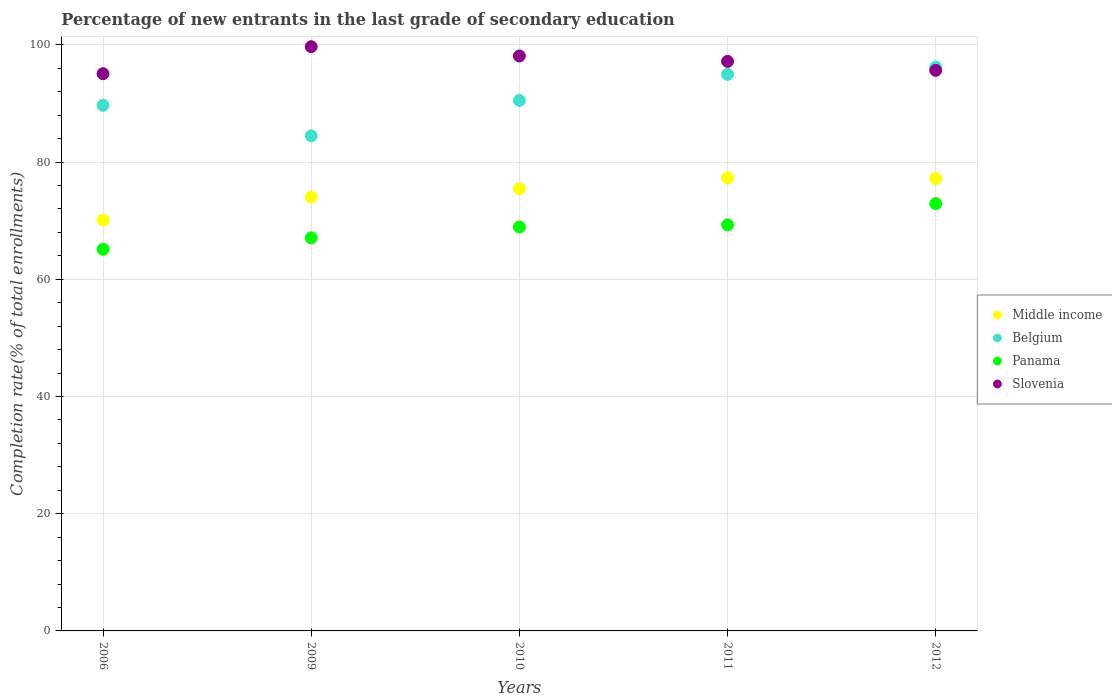What is the percentage of new entrants in Middle income in 2012?
Offer a very short reply. 77.19. Across all years, what is the maximum percentage of new entrants in Middle income?
Ensure brevity in your answer.  77.31. Across all years, what is the minimum percentage of new entrants in Panama?
Give a very brief answer. 65.11. In which year was the percentage of new entrants in Slovenia maximum?
Offer a very short reply. 2009. In which year was the percentage of new entrants in Slovenia minimum?
Your response must be concise. 2006. What is the total percentage of new entrants in Panama in the graph?
Provide a short and direct response. 343.26. What is the difference between the percentage of new entrants in Belgium in 2009 and that in 2010?
Your answer should be very brief. -6.04. What is the difference between the percentage of new entrants in Slovenia in 2006 and the percentage of new entrants in Panama in 2009?
Provide a succinct answer. 28. What is the average percentage of new entrants in Slovenia per year?
Your answer should be compact. 97.13. In the year 2006, what is the difference between the percentage of new entrants in Belgium and percentage of new entrants in Middle income?
Keep it short and to the point. 19.57. In how many years, is the percentage of new entrants in Belgium greater than 80 %?
Provide a short and direct response. 5. What is the ratio of the percentage of new entrants in Panama in 2009 to that in 2010?
Keep it short and to the point. 0.97. What is the difference between the highest and the second highest percentage of new entrants in Panama?
Your response must be concise. 3.62. What is the difference between the highest and the lowest percentage of new entrants in Belgium?
Your answer should be very brief. 11.74. Is it the case that in every year, the sum of the percentage of new entrants in Slovenia and percentage of new entrants in Belgium  is greater than the sum of percentage of new entrants in Middle income and percentage of new entrants in Panama?
Make the answer very short. Yes. Is it the case that in every year, the sum of the percentage of new entrants in Slovenia and percentage of new entrants in Panama  is greater than the percentage of new entrants in Belgium?
Offer a very short reply. Yes. Does the percentage of new entrants in Slovenia monotonically increase over the years?
Provide a short and direct response. No. Is the percentage of new entrants in Middle income strictly greater than the percentage of new entrants in Panama over the years?
Your response must be concise. Yes. Is the percentage of new entrants in Slovenia strictly less than the percentage of new entrants in Panama over the years?
Give a very brief answer. No. What is the difference between two consecutive major ticks on the Y-axis?
Give a very brief answer. 20. Are the values on the major ticks of Y-axis written in scientific E-notation?
Your answer should be very brief. No. Where does the legend appear in the graph?
Your answer should be compact. Center right. How are the legend labels stacked?
Offer a terse response. Vertical. What is the title of the graph?
Give a very brief answer. Percentage of new entrants in the last grade of secondary education. What is the label or title of the X-axis?
Your response must be concise. Years. What is the label or title of the Y-axis?
Give a very brief answer. Completion rate(% of total enrollments). What is the Completion rate(% of total enrollments) of Middle income in 2006?
Make the answer very short. 70.1. What is the Completion rate(% of total enrollments) in Belgium in 2006?
Provide a succinct answer. 89.67. What is the Completion rate(% of total enrollments) in Panama in 2006?
Offer a very short reply. 65.11. What is the Completion rate(% of total enrollments) in Slovenia in 2006?
Make the answer very short. 95.07. What is the Completion rate(% of total enrollments) of Middle income in 2009?
Offer a very short reply. 74.01. What is the Completion rate(% of total enrollments) of Belgium in 2009?
Provide a succinct answer. 84.47. What is the Completion rate(% of total enrollments) in Panama in 2009?
Provide a succinct answer. 67.06. What is the Completion rate(% of total enrollments) of Slovenia in 2009?
Make the answer very short. 99.67. What is the Completion rate(% of total enrollments) in Middle income in 2010?
Provide a short and direct response. 75.43. What is the Completion rate(% of total enrollments) of Belgium in 2010?
Your answer should be very brief. 90.5. What is the Completion rate(% of total enrollments) of Panama in 2010?
Make the answer very short. 68.91. What is the Completion rate(% of total enrollments) in Slovenia in 2010?
Provide a short and direct response. 98.09. What is the Completion rate(% of total enrollments) of Middle income in 2011?
Offer a terse response. 77.31. What is the Completion rate(% of total enrollments) in Belgium in 2011?
Provide a short and direct response. 94.96. What is the Completion rate(% of total enrollments) of Panama in 2011?
Your response must be concise. 69.28. What is the Completion rate(% of total enrollments) in Slovenia in 2011?
Make the answer very short. 97.17. What is the Completion rate(% of total enrollments) of Middle income in 2012?
Your response must be concise. 77.19. What is the Completion rate(% of total enrollments) in Belgium in 2012?
Your response must be concise. 96.2. What is the Completion rate(% of total enrollments) of Panama in 2012?
Your response must be concise. 72.9. What is the Completion rate(% of total enrollments) of Slovenia in 2012?
Offer a very short reply. 95.64. Across all years, what is the maximum Completion rate(% of total enrollments) of Middle income?
Make the answer very short. 77.31. Across all years, what is the maximum Completion rate(% of total enrollments) in Belgium?
Offer a very short reply. 96.2. Across all years, what is the maximum Completion rate(% of total enrollments) of Panama?
Ensure brevity in your answer.  72.9. Across all years, what is the maximum Completion rate(% of total enrollments) in Slovenia?
Keep it short and to the point. 99.67. Across all years, what is the minimum Completion rate(% of total enrollments) in Middle income?
Give a very brief answer. 70.1. Across all years, what is the minimum Completion rate(% of total enrollments) in Belgium?
Your answer should be very brief. 84.47. Across all years, what is the minimum Completion rate(% of total enrollments) of Panama?
Make the answer very short. 65.11. Across all years, what is the minimum Completion rate(% of total enrollments) of Slovenia?
Give a very brief answer. 95.07. What is the total Completion rate(% of total enrollments) of Middle income in the graph?
Give a very brief answer. 374.03. What is the total Completion rate(% of total enrollments) in Belgium in the graph?
Offer a terse response. 455.8. What is the total Completion rate(% of total enrollments) of Panama in the graph?
Keep it short and to the point. 343.26. What is the total Completion rate(% of total enrollments) in Slovenia in the graph?
Offer a very short reply. 485.63. What is the difference between the Completion rate(% of total enrollments) in Middle income in 2006 and that in 2009?
Offer a very short reply. -3.92. What is the difference between the Completion rate(% of total enrollments) in Belgium in 2006 and that in 2009?
Keep it short and to the point. 5.2. What is the difference between the Completion rate(% of total enrollments) of Panama in 2006 and that in 2009?
Offer a terse response. -1.96. What is the difference between the Completion rate(% of total enrollments) in Slovenia in 2006 and that in 2009?
Provide a short and direct response. -4.6. What is the difference between the Completion rate(% of total enrollments) in Middle income in 2006 and that in 2010?
Your answer should be very brief. -5.33. What is the difference between the Completion rate(% of total enrollments) of Belgium in 2006 and that in 2010?
Provide a succinct answer. -0.84. What is the difference between the Completion rate(% of total enrollments) in Panama in 2006 and that in 2010?
Your answer should be compact. -3.8. What is the difference between the Completion rate(% of total enrollments) in Slovenia in 2006 and that in 2010?
Provide a short and direct response. -3.02. What is the difference between the Completion rate(% of total enrollments) of Middle income in 2006 and that in 2011?
Give a very brief answer. -7.21. What is the difference between the Completion rate(% of total enrollments) in Belgium in 2006 and that in 2011?
Make the answer very short. -5.29. What is the difference between the Completion rate(% of total enrollments) in Panama in 2006 and that in 2011?
Your response must be concise. -4.17. What is the difference between the Completion rate(% of total enrollments) of Slovenia in 2006 and that in 2011?
Keep it short and to the point. -2.1. What is the difference between the Completion rate(% of total enrollments) of Middle income in 2006 and that in 2012?
Give a very brief answer. -7.09. What is the difference between the Completion rate(% of total enrollments) in Belgium in 2006 and that in 2012?
Provide a short and direct response. -6.54. What is the difference between the Completion rate(% of total enrollments) in Panama in 2006 and that in 2012?
Your response must be concise. -7.8. What is the difference between the Completion rate(% of total enrollments) in Slovenia in 2006 and that in 2012?
Provide a short and direct response. -0.57. What is the difference between the Completion rate(% of total enrollments) of Middle income in 2009 and that in 2010?
Keep it short and to the point. -1.42. What is the difference between the Completion rate(% of total enrollments) in Belgium in 2009 and that in 2010?
Your response must be concise. -6.04. What is the difference between the Completion rate(% of total enrollments) of Panama in 2009 and that in 2010?
Offer a terse response. -1.85. What is the difference between the Completion rate(% of total enrollments) in Slovenia in 2009 and that in 2010?
Offer a terse response. 1.58. What is the difference between the Completion rate(% of total enrollments) in Middle income in 2009 and that in 2011?
Offer a very short reply. -3.3. What is the difference between the Completion rate(% of total enrollments) in Belgium in 2009 and that in 2011?
Offer a terse response. -10.49. What is the difference between the Completion rate(% of total enrollments) of Panama in 2009 and that in 2011?
Your answer should be very brief. -2.21. What is the difference between the Completion rate(% of total enrollments) of Slovenia in 2009 and that in 2011?
Offer a very short reply. 2.5. What is the difference between the Completion rate(% of total enrollments) in Middle income in 2009 and that in 2012?
Provide a succinct answer. -3.17. What is the difference between the Completion rate(% of total enrollments) of Belgium in 2009 and that in 2012?
Give a very brief answer. -11.74. What is the difference between the Completion rate(% of total enrollments) of Panama in 2009 and that in 2012?
Your response must be concise. -5.84. What is the difference between the Completion rate(% of total enrollments) in Slovenia in 2009 and that in 2012?
Your answer should be compact. 4.04. What is the difference between the Completion rate(% of total enrollments) in Middle income in 2010 and that in 2011?
Give a very brief answer. -1.88. What is the difference between the Completion rate(% of total enrollments) of Belgium in 2010 and that in 2011?
Provide a short and direct response. -4.45. What is the difference between the Completion rate(% of total enrollments) in Panama in 2010 and that in 2011?
Your answer should be very brief. -0.37. What is the difference between the Completion rate(% of total enrollments) in Slovenia in 2010 and that in 2011?
Your answer should be very brief. 0.92. What is the difference between the Completion rate(% of total enrollments) of Middle income in 2010 and that in 2012?
Keep it short and to the point. -1.76. What is the difference between the Completion rate(% of total enrollments) in Belgium in 2010 and that in 2012?
Keep it short and to the point. -5.7. What is the difference between the Completion rate(% of total enrollments) of Panama in 2010 and that in 2012?
Give a very brief answer. -3.99. What is the difference between the Completion rate(% of total enrollments) in Slovenia in 2010 and that in 2012?
Your response must be concise. 2.45. What is the difference between the Completion rate(% of total enrollments) of Middle income in 2011 and that in 2012?
Offer a terse response. 0.12. What is the difference between the Completion rate(% of total enrollments) of Belgium in 2011 and that in 2012?
Provide a succinct answer. -1.25. What is the difference between the Completion rate(% of total enrollments) of Panama in 2011 and that in 2012?
Give a very brief answer. -3.62. What is the difference between the Completion rate(% of total enrollments) of Slovenia in 2011 and that in 2012?
Your response must be concise. 1.53. What is the difference between the Completion rate(% of total enrollments) in Middle income in 2006 and the Completion rate(% of total enrollments) in Belgium in 2009?
Make the answer very short. -14.37. What is the difference between the Completion rate(% of total enrollments) in Middle income in 2006 and the Completion rate(% of total enrollments) in Panama in 2009?
Provide a succinct answer. 3.03. What is the difference between the Completion rate(% of total enrollments) of Middle income in 2006 and the Completion rate(% of total enrollments) of Slovenia in 2009?
Keep it short and to the point. -29.58. What is the difference between the Completion rate(% of total enrollments) of Belgium in 2006 and the Completion rate(% of total enrollments) of Panama in 2009?
Your answer should be very brief. 22.6. What is the difference between the Completion rate(% of total enrollments) in Belgium in 2006 and the Completion rate(% of total enrollments) in Slovenia in 2009?
Provide a succinct answer. -10. What is the difference between the Completion rate(% of total enrollments) of Panama in 2006 and the Completion rate(% of total enrollments) of Slovenia in 2009?
Your answer should be compact. -34.56. What is the difference between the Completion rate(% of total enrollments) in Middle income in 2006 and the Completion rate(% of total enrollments) in Belgium in 2010?
Offer a very short reply. -20.41. What is the difference between the Completion rate(% of total enrollments) in Middle income in 2006 and the Completion rate(% of total enrollments) in Panama in 2010?
Keep it short and to the point. 1.19. What is the difference between the Completion rate(% of total enrollments) of Middle income in 2006 and the Completion rate(% of total enrollments) of Slovenia in 2010?
Your answer should be very brief. -27.99. What is the difference between the Completion rate(% of total enrollments) of Belgium in 2006 and the Completion rate(% of total enrollments) of Panama in 2010?
Provide a succinct answer. 20.76. What is the difference between the Completion rate(% of total enrollments) in Belgium in 2006 and the Completion rate(% of total enrollments) in Slovenia in 2010?
Ensure brevity in your answer.  -8.42. What is the difference between the Completion rate(% of total enrollments) of Panama in 2006 and the Completion rate(% of total enrollments) of Slovenia in 2010?
Give a very brief answer. -32.98. What is the difference between the Completion rate(% of total enrollments) of Middle income in 2006 and the Completion rate(% of total enrollments) of Belgium in 2011?
Give a very brief answer. -24.86. What is the difference between the Completion rate(% of total enrollments) in Middle income in 2006 and the Completion rate(% of total enrollments) in Panama in 2011?
Give a very brief answer. 0.82. What is the difference between the Completion rate(% of total enrollments) in Middle income in 2006 and the Completion rate(% of total enrollments) in Slovenia in 2011?
Offer a terse response. -27.07. What is the difference between the Completion rate(% of total enrollments) of Belgium in 2006 and the Completion rate(% of total enrollments) of Panama in 2011?
Offer a very short reply. 20.39. What is the difference between the Completion rate(% of total enrollments) of Belgium in 2006 and the Completion rate(% of total enrollments) of Slovenia in 2011?
Ensure brevity in your answer.  -7.5. What is the difference between the Completion rate(% of total enrollments) of Panama in 2006 and the Completion rate(% of total enrollments) of Slovenia in 2011?
Give a very brief answer. -32.06. What is the difference between the Completion rate(% of total enrollments) in Middle income in 2006 and the Completion rate(% of total enrollments) in Belgium in 2012?
Offer a terse response. -26.11. What is the difference between the Completion rate(% of total enrollments) of Middle income in 2006 and the Completion rate(% of total enrollments) of Panama in 2012?
Your answer should be very brief. -2.81. What is the difference between the Completion rate(% of total enrollments) in Middle income in 2006 and the Completion rate(% of total enrollments) in Slovenia in 2012?
Ensure brevity in your answer.  -25.54. What is the difference between the Completion rate(% of total enrollments) of Belgium in 2006 and the Completion rate(% of total enrollments) of Panama in 2012?
Keep it short and to the point. 16.77. What is the difference between the Completion rate(% of total enrollments) of Belgium in 2006 and the Completion rate(% of total enrollments) of Slovenia in 2012?
Your response must be concise. -5.97. What is the difference between the Completion rate(% of total enrollments) in Panama in 2006 and the Completion rate(% of total enrollments) in Slovenia in 2012?
Make the answer very short. -30.53. What is the difference between the Completion rate(% of total enrollments) of Middle income in 2009 and the Completion rate(% of total enrollments) of Belgium in 2010?
Provide a succinct answer. -16.49. What is the difference between the Completion rate(% of total enrollments) in Middle income in 2009 and the Completion rate(% of total enrollments) in Panama in 2010?
Your response must be concise. 5.1. What is the difference between the Completion rate(% of total enrollments) of Middle income in 2009 and the Completion rate(% of total enrollments) of Slovenia in 2010?
Provide a succinct answer. -24.08. What is the difference between the Completion rate(% of total enrollments) of Belgium in 2009 and the Completion rate(% of total enrollments) of Panama in 2010?
Ensure brevity in your answer.  15.56. What is the difference between the Completion rate(% of total enrollments) in Belgium in 2009 and the Completion rate(% of total enrollments) in Slovenia in 2010?
Offer a very short reply. -13.62. What is the difference between the Completion rate(% of total enrollments) in Panama in 2009 and the Completion rate(% of total enrollments) in Slovenia in 2010?
Offer a terse response. -31.03. What is the difference between the Completion rate(% of total enrollments) of Middle income in 2009 and the Completion rate(% of total enrollments) of Belgium in 2011?
Your answer should be very brief. -20.94. What is the difference between the Completion rate(% of total enrollments) of Middle income in 2009 and the Completion rate(% of total enrollments) of Panama in 2011?
Give a very brief answer. 4.73. What is the difference between the Completion rate(% of total enrollments) of Middle income in 2009 and the Completion rate(% of total enrollments) of Slovenia in 2011?
Ensure brevity in your answer.  -23.15. What is the difference between the Completion rate(% of total enrollments) in Belgium in 2009 and the Completion rate(% of total enrollments) in Panama in 2011?
Make the answer very short. 15.19. What is the difference between the Completion rate(% of total enrollments) of Belgium in 2009 and the Completion rate(% of total enrollments) of Slovenia in 2011?
Keep it short and to the point. -12.7. What is the difference between the Completion rate(% of total enrollments) in Panama in 2009 and the Completion rate(% of total enrollments) in Slovenia in 2011?
Provide a short and direct response. -30.1. What is the difference between the Completion rate(% of total enrollments) in Middle income in 2009 and the Completion rate(% of total enrollments) in Belgium in 2012?
Ensure brevity in your answer.  -22.19. What is the difference between the Completion rate(% of total enrollments) of Middle income in 2009 and the Completion rate(% of total enrollments) of Panama in 2012?
Make the answer very short. 1.11. What is the difference between the Completion rate(% of total enrollments) of Middle income in 2009 and the Completion rate(% of total enrollments) of Slovenia in 2012?
Ensure brevity in your answer.  -21.62. What is the difference between the Completion rate(% of total enrollments) in Belgium in 2009 and the Completion rate(% of total enrollments) in Panama in 2012?
Provide a short and direct response. 11.57. What is the difference between the Completion rate(% of total enrollments) in Belgium in 2009 and the Completion rate(% of total enrollments) in Slovenia in 2012?
Offer a terse response. -11.17. What is the difference between the Completion rate(% of total enrollments) of Panama in 2009 and the Completion rate(% of total enrollments) of Slovenia in 2012?
Ensure brevity in your answer.  -28.57. What is the difference between the Completion rate(% of total enrollments) in Middle income in 2010 and the Completion rate(% of total enrollments) in Belgium in 2011?
Your answer should be very brief. -19.53. What is the difference between the Completion rate(% of total enrollments) in Middle income in 2010 and the Completion rate(% of total enrollments) in Panama in 2011?
Your response must be concise. 6.15. What is the difference between the Completion rate(% of total enrollments) of Middle income in 2010 and the Completion rate(% of total enrollments) of Slovenia in 2011?
Offer a terse response. -21.74. What is the difference between the Completion rate(% of total enrollments) in Belgium in 2010 and the Completion rate(% of total enrollments) in Panama in 2011?
Keep it short and to the point. 21.23. What is the difference between the Completion rate(% of total enrollments) of Belgium in 2010 and the Completion rate(% of total enrollments) of Slovenia in 2011?
Your answer should be compact. -6.66. What is the difference between the Completion rate(% of total enrollments) of Panama in 2010 and the Completion rate(% of total enrollments) of Slovenia in 2011?
Make the answer very short. -28.26. What is the difference between the Completion rate(% of total enrollments) of Middle income in 2010 and the Completion rate(% of total enrollments) of Belgium in 2012?
Keep it short and to the point. -20.78. What is the difference between the Completion rate(% of total enrollments) of Middle income in 2010 and the Completion rate(% of total enrollments) of Panama in 2012?
Keep it short and to the point. 2.53. What is the difference between the Completion rate(% of total enrollments) in Middle income in 2010 and the Completion rate(% of total enrollments) in Slovenia in 2012?
Your answer should be very brief. -20.21. What is the difference between the Completion rate(% of total enrollments) of Belgium in 2010 and the Completion rate(% of total enrollments) of Panama in 2012?
Your answer should be very brief. 17.6. What is the difference between the Completion rate(% of total enrollments) of Belgium in 2010 and the Completion rate(% of total enrollments) of Slovenia in 2012?
Offer a very short reply. -5.13. What is the difference between the Completion rate(% of total enrollments) in Panama in 2010 and the Completion rate(% of total enrollments) in Slovenia in 2012?
Provide a short and direct response. -26.73. What is the difference between the Completion rate(% of total enrollments) of Middle income in 2011 and the Completion rate(% of total enrollments) of Belgium in 2012?
Keep it short and to the point. -18.89. What is the difference between the Completion rate(% of total enrollments) of Middle income in 2011 and the Completion rate(% of total enrollments) of Panama in 2012?
Your answer should be very brief. 4.41. What is the difference between the Completion rate(% of total enrollments) in Middle income in 2011 and the Completion rate(% of total enrollments) in Slovenia in 2012?
Your answer should be very brief. -18.33. What is the difference between the Completion rate(% of total enrollments) of Belgium in 2011 and the Completion rate(% of total enrollments) of Panama in 2012?
Your answer should be very brief. 22.06. What is the difference between the Completion rate(% of total enrollments) in Belgium in 2011 and the Completion rate(% of total enrollments) in Slovenia in 2012?
Your answer should be very brief. -0.68. What is the difference between the Completion rate(% of total enrollments) of Panama in 2011 and the Completion rate(% of total enrollments) of Slovenia in 2012?
Make the answer very short. -26.36. What is the average Completion rate(% of total enrollments) in Middle income per year?
Give a very brief answer. 74.81. What is the average Completion rate(% of total enrollments) in Belgium per year?
Your response must be concise. 91.16. What is the average Completion rate(% of total enrollments) in Panama per year?
Make the answer very short. 68.65. What is the average Completion rate(% of total enrollments) in Slovenia per year?
Keep it short and to the point. 97.13. In the year 2006, what is the difference between the Completion rate(% of total enrollments) of Middle income and Completion rate(% of total enrollments) of Belgium?
Offer a very short reply. -19.57. In the year 2006, what is the difference between the Completion rate(% of total enrollments) in Middle income and Completion rate(% of total enrollments) in Panama?
Give a very brief answer. 4.99. In the year 2006, what is the difference between the Completion rate(% of total enrollments) of Middle income and Completion rate(% of total enrollments) of Slovenia?
Give a very brief answer. -24.97. In the year 2006, what is the difference between the Completion rate(% of total enrollments) in Belgium and Completion rate(% of total enrollments) in Panama?
Your response must be concise. 24.56. In the year 2006, what is the difference between the Completion rate(% of total enrollments) in Belgium and Completion rate(% of total enrollments) in Slovenia?
Provide a short and direct response. -5.4. In the year 2006, what is the difference between the Completion rate(% of total enrollments) in Panama and Completion rate(% of total enrollments) in Slovenia?
Your response must be concise. -29.96. In the year 2009, what is the difference between the Completion rate(% of total enrollments) of Middle income and Completion rate(% of total enrollments) of Belgium?
Provide a short and direct response. -10.46. In the year 2009, what is the difference between the Completion rate(% of total enrollments) of Middle income and Completion rate(% of total enrollments) of Panama?
Ensure brevity in your answer.  6.95. In the year 2009, what is the difference between the Completion rate(% of total enrollments) in Middle income and Completion rate(% of total enrollments) in Slovenia?
Offer a very short reply. -25.66. In the year 2009, what is the difference between the Completion rate(% of total enrollments) in Belgium and Completion rate(% of total enrollments) in Panama?
Your answer should be very brief. 17.4. In the year 2009, what is the difference between the Completion rate(% of total enrollments) of Belgium and Completion rate(% of total enrollments) of Slovenia?
Your answer should be very brief. -15.2. In the year 2009, what is the difference between the Completion rate(% of total enrollments) in Panama and Completion rate(% of total enrollments) in Slovenia?
Provide a succinct answer. -32.61. In the year 2010, what is the difference between the Completion rate(% of total enrollments) in Middle income and Completion rate(% of total enrollments) in Belgium?
Your answer should be very brief. -15.08. In the year 2010, what is the difference between the Completion rate(% of total enrollments) in Middle income and Completion rate(% of total enrollments) in Panama?
Give a very brief answer. 6.52. In the year 2010, what is the difference between the Completion rate(% of total enrollments) in Middle income and Completion rate(% of total enrollments) in Slovenia?
Your response must be concise. -22.66. In the year 2010, what is the difference between the Completion rate(% of total enrollments) in Belgium and Completion rate(% of total enrollments) in Panama?
Provide a short and direct response. 21.6. In the year 2010, what is the difference between the Completion rate(% of total enrollments) of Belgium and Completion rate(% of total enrollments) of Slovenia?
Offer a very short reply. -7.58. In the year 2010, what is the difference between the Completion rate(% of total enrollments) in Panama and Completion rate(% of total enrollments) in Slovenia?
Make the answer very short. -29.18. In the year 2011, what is the difference between the Completion rate(% of total enrollments) in Middle income and Completion rate(% of total enrollments) in Belgium?
Offer a terse response. -17.65. In the year 2011, what is the difference between the Completion rate(% of total enrollments) of Middle income and Completion rate(% of total enrollments) of Panama?
Make the answer very short. 8.03. In the year 2011, what is the difference between the Completion rate(% of total enrollments) in Middle income and Completion rate(% of total enrollments) in Slovenia?
Offer a terse response. -19.86. In the year 2011, what is the difference between the Completion rate(% of total enrollments) of Belgium and Completion rate(% of total enrollments) of Panama?
Give a very brief answer. 25.68. In the year 2011, what is the difference between the Completion rate(% of total enrollments) of Belgium and Completion rate(% of total enrollments) of Slovenia?
Your answer should be very brief. -2.21. In the year 2011, what is the difference between the Completion rate(% of total enrollments) in Panama and Completion rate(% of total enrollments) in Slovenia?
Keep it short and to the point. -27.89. In the year 2012, what is the difference between the Completion rate(% of total enrollments) in Middle income and Completion rate(% of total enrollments) in Belgium?
Offer a very short reply. -19.02. In the year 2012, what is the difference between the Completion rate(% of total enrollments) of Middle income and Completion rate(% of total enrollments) of Panama?
Offer a very short reply. 4.28. In the year 2012, what is the difference between the Completion rate(% of total enrollments) in Middle income and Completion rate(% of total enrollments) in Slovenia?
Your response must be concise. -18.45. In the year 2012, what is the difference between the Completion rate(% of total enrollments) of Belgium and Completion rate(% of total enrollments) of Panama?
Your response must be concise. 23.3. In the year 2012, what is the difference between the Completion rate(% of total enrollments) in Belgium and Completion rate(% of total enrollments) in Slovenia?
Your response must be concise. 0.57. In the year 2012, what is the difference between the Completion rate(% of total enrollments) of Panama and Completion rate(% of total enrollments) of Slovenia?
Ensure brevity in your answer.  -22.73. What is the ratio of the Completion rate(% of total enrollments) of Middle income in 2006 to that in 2009?
Give a very brief answer. 0.95. What is the ratio of the Completion rate(% of total enrollments) in Belgium in 2006 to that in 2009?
Provide a succinct answer. 1.06. What is the ratio of the Completion rate(% of total enrollments) in Panama in 2006 to that in 2009?
Make the answer very short. 0.97. What is the ratio of the Completion rate(% of total enrollments) in Slovenia in 2006 to that in 2009?
Your response must be concise. 0.95. What is the ratio of the Completion rate(% of total enrollments) in Middle income in 2006 to that in 2010?
Make the answer very short. 0.93. What is the ratio of the Completion rate(% of total enrollments) in Panama in 2006 to that in 2010?
Your response must be concise. 0.94. What is the ratio of the Completion rate(% of total enrollments) of Slovenia in 2006 to that in 2010?
Offer a very short reply. 0.97. What is the ratio of the Completion rate(% of total enrollments) in Middle income in 2006 to that in 2011?
Offer a terse response. 0.91. What is the ratio of the Completion rate(% of total enrollments) in Belgium in 2006 to that in 2011?
Keep it short and to the point. 0.94. What is the ratio of the Completion rate(% of total enrollments) of Panama in 2006 to that in 2011?
Your answer should be compact. 0.94. What is the ratio of the Completion rate(% of total enrollments) in Slovenia in 2006 to that in 2011?
Your answer should be very brief. 0.98. What is the ratio of the Completion rate(% of total enrollments) in Middle income in 2006 to that in 2012?
Make the answer very short. 0.91. What is the ratio of the Completion rate(% of total enrollments) of Belgium in 2006 to that in 2012?
Your answer should be compact. 0.93. What is the ratio of the Completion rate(% of total enrollments) in Panama in 2006 to that in 2012?
Provide a succinct answer. 0.89. What is the ratio of the Completion rate(% of total enrollments) in Slovenia in 2006 to that in 2012?
Your response must be concise. 0.99. What is the ratio of the Completion rate(% of total enrollments) in Middle income in 2009 to that in 2010?
Ensure brevity in your answer.  0.98. What is the ratio of the Completion rate(% of total enrollments) in Belgium in 2009 to that in 2010?
Give a very brief answer. 0.93. What is the ratio of the Completion rate(% of total enrollments) of Panama in 2009 to that in 2010?
Provide a short and direct response. 0.97. What is the ratio of the Completion rate(% of total enrollments) of Slovenia in 2009 to that in 2010?
Make the answer very short. 1.02. What is the ratio of the Completion rate(% of total enrollments) in Middle income in 2009 to that in 2011?
Give a very brief answer. 0.96. What is the ratio of the Completion rate(% of total enrollments) in Belgium in 2009 to that in 2011?
Make the answer very short. 0.89. What is the ratio of the Completion rate(% of total enrollments) of Panama in 2009 to that in 2011?
Provide a succinct answer. 0.97. What is the ratio of the Completion rate(% of total enrollments) of Slovenia in 2009 to that in 2011?
Offer a terse response. 1.03. What is the ratio of the Completion rate(% of total enrollments) in Middle income in 2009 to that in 2012?
Give a very brief answer. 0.96. What is the ratio of the Completion rate(% of total enrollments) of Belgium in 2009 to that in 2012?
Your response must be concise. 0.88. What is the ratio of the Completion rate(% of total enrollments) in Panama in 2009 to that in 2012?
Make the answer very short. 0.92. What is the ratio of the Completion rate(% of total enrollments) in Slovenia in 2009 to that in 2012?
Provide a short and direct response. 1.04. What is the ratio of the Completion rate(% of total enrollments) in Middle income in 2010 to that in 2011?
Offer a very short reply. 0.98. What is the ratio of the Completion rate(% of total enrollments) of Belgium in 2010 to that in 2011?
Offer a terse response. 0.95. What is the ratio of the Completion rate(% of total enrollments) of Slovenia in 2010 to that in 2011?
Your answer should be very brief. 1.01. What is the ratio of the Completion rate(% of total enrollments) of Middle income in 2010 to that in 2012?
Provide a short and direct response. 0.98. What is the ratio of the Completion rate(% of total enrollments) of Belgium in 2010 to that in 2012?
Your response must be concise. 0.94. What is the ratio of the Completion rate(% of total enrollments) in Panama in 2010 to that in 2012?
Offer a terse response. 0.95. What is the ratio of the Completion rate(% of total enrollments) in Slovenia in 2010 to that in 2012?
Ensure brevity in your answer.  1.03. What is the ratio of the Completion rate(% of total enrollments) in Panama in 2011 to that in 2012?
Provide a short and direct response. 0.95. What is the ratio of the Completion rate(% of total enrollments) in Slovenia in 2011 to that in 2012?
Give a very brief answer. 1.02. What is the difference between the highest and the second highest Completion rate(% of total enrollments) in Middle income?
Offer a terse response. 0.12. What is the difference between the highest and the second highest Completion rate(% of total enrollments) in Belgium?
Give a very brief answer. 1.25. What is the difference between the highest and the second highest Completion rate(% of total enrollments) in Panama?
Ensure brevity in your answer.  3.62. What is the difference between the highest and the second highest Completion rate(% of total enrollments) of Slovenia?
Your response must be concise. 1.58. What is the difference between the highest and the lowest Completion rate(% of total enrollments) in Middle income?
Ensure brevity in your answer.  7.21. What is the difference between the highest and the lowest Completion rate(% of total enrollments) of Belgium?
Give a very brief answer. 11.74. What is the difference between the highest and the lowest Completion rate(% of total enrollments) of Panama?
Ensure brevity in your answer.  7.8. What is the difference between the highest and the lowest Completion rate(% of total enrollments) of Slovenia?
Offer a terse response. 4.6. 